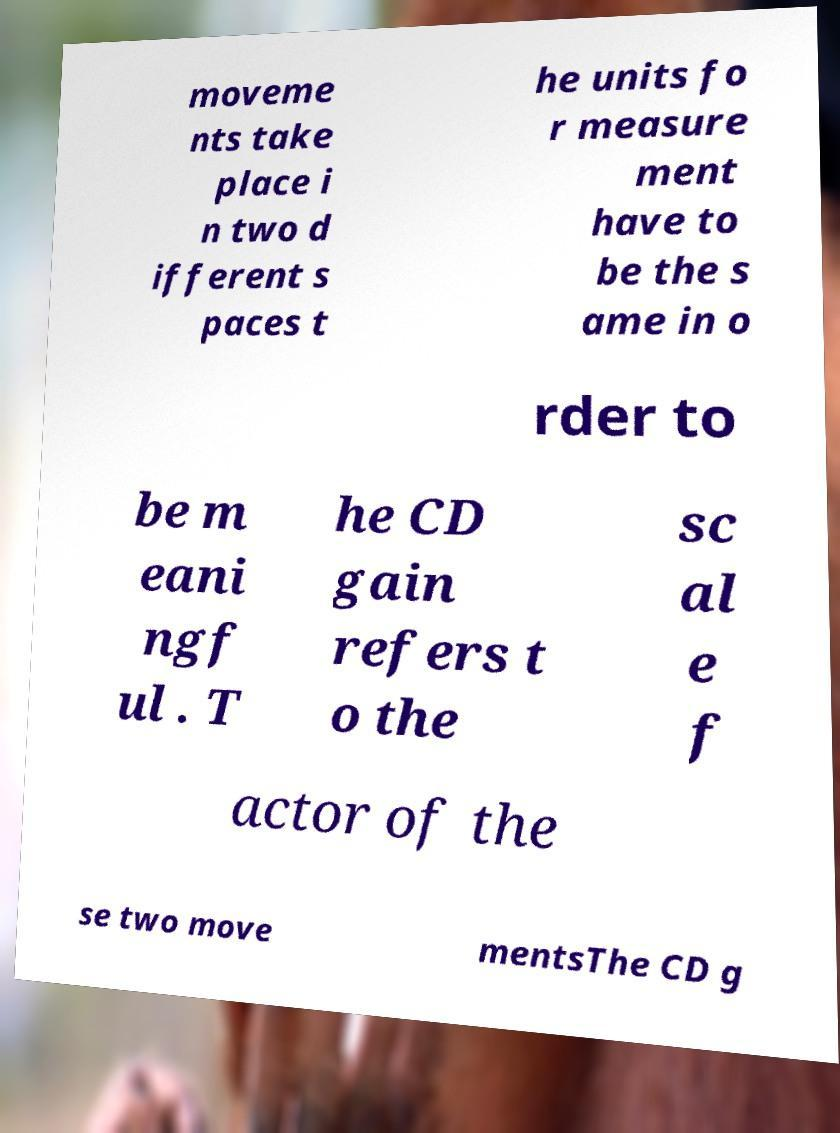Can you accurately transcribe the text from the provided image for me? moveme nts take place i n two d ifferent s paces t he units fo r measure ment have to be the s ame in o rder to be m eani ngf ul . T he CD gain refers t o the sc al e f actor of the se two move mentsThe CD g 